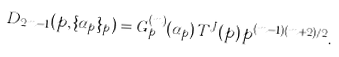Convert formula to latex. <formula><loc_0><loc_0><loc_500><loc_500>D _ { 2 m - 1 } ( p , \{ \alpha _ { p } \} _ { p } ) = G _ { p } ^ { ( m ) } ( \alpha _ { p } ) \, T ^ { J } ( p ) \, p ^ { ( m - 1 ) ( m + 2 ) / 2 } .</formula> 